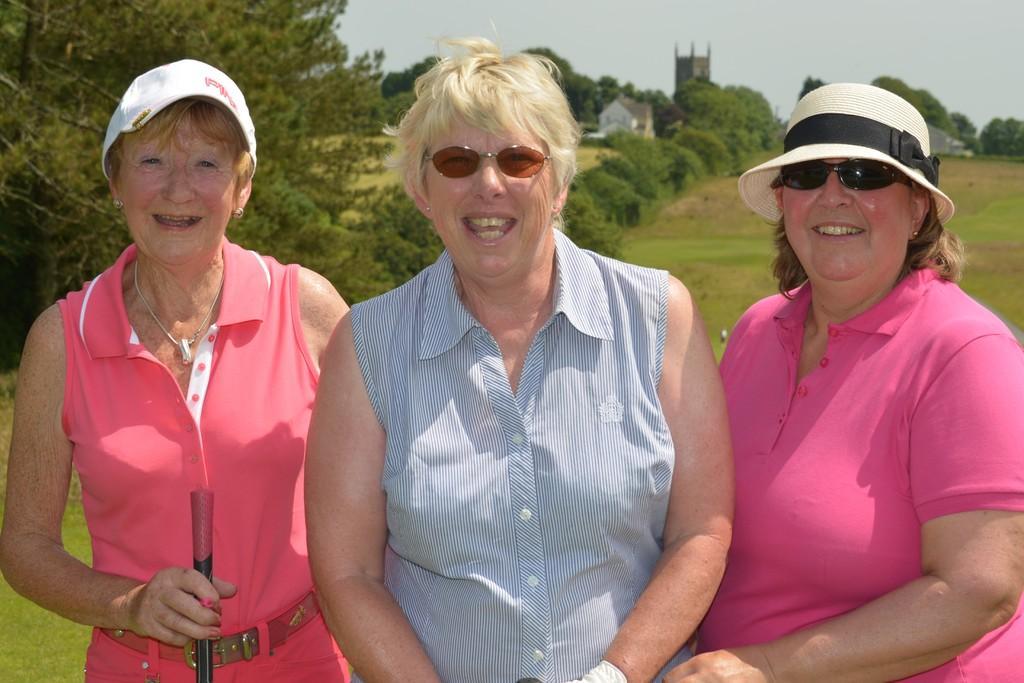In one or two sentences, can you explain what this image depicts? In this picture I can observe three women standing on the land. All of them are smiling. Two of them are wearing spectacles. One of them is wearing a hat on her head. In the background there are plants and trees on the ground. I can observe a sky. 